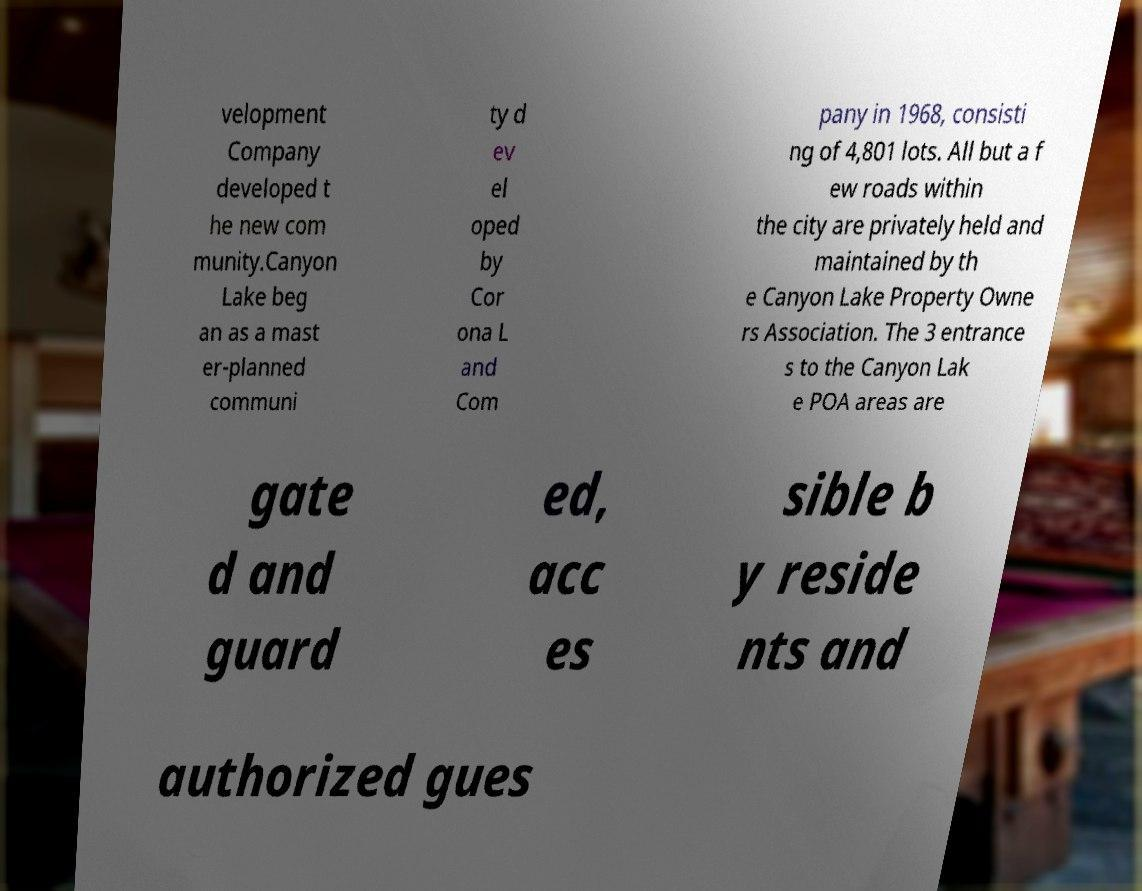Could you extract and type out the text from this image? velopment Company developed t he new com munity.Canyon Lake beg an as a mast er-planned communi ty d ev el oped by Cor ona L and Com pany in 1968, consisti ng of 4,801 lots. All but a f ew roads within the city are privately held and maintained by th e Canyon Lake Property Owne rs Association. The 3 entrance s to the Canyon Lak e POA areas are gate d and guard ed, acc es sible b y reside nts and authorized gues 